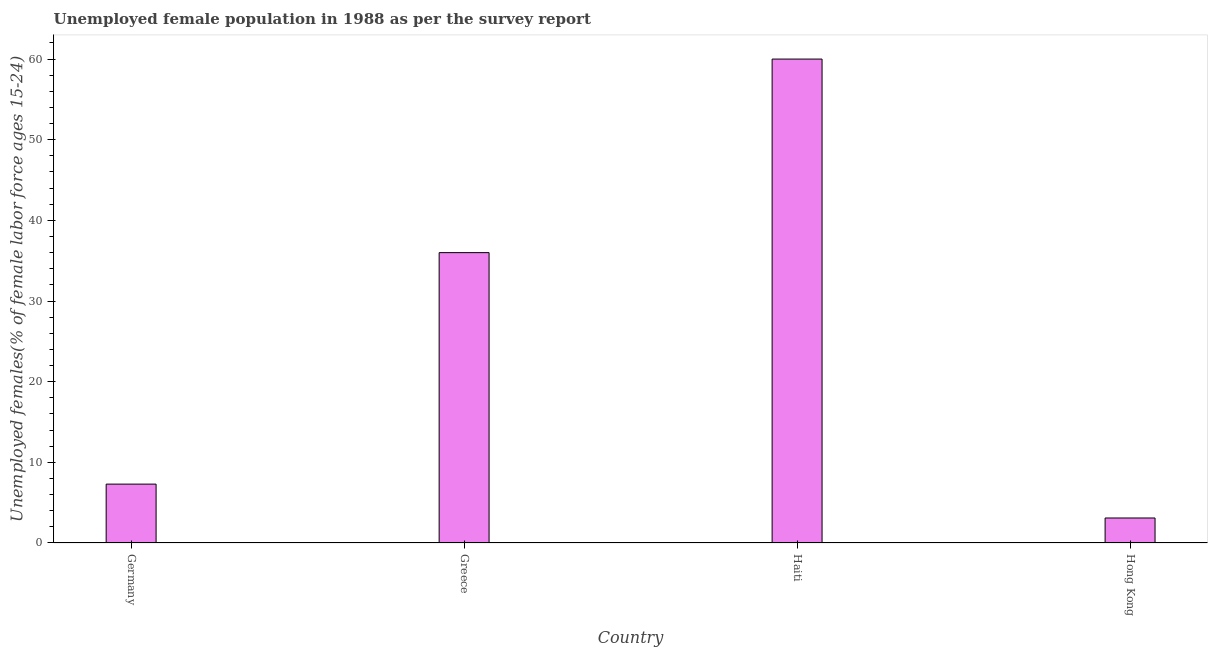Does the graph contain grids?
Your answer should be very brief. No. What is the title of the graph?
Provide a short and direct response. Unemployed female population in 1988 as per the survey report. What is the label or title of the X-axis?
Provide a succinct answer. Country. What is the label or title of the Y-axis?
Provide a succinct answer. Unemployed females(% of female labor force ages 15-24). Across all countries, what is the maximum unemployed female youth?
Keep it short and to the point. 60. Across all countries, what is the minimum unemployed female youth?
Offer a terse response. 3.1. In which country was the unemployed female youth maximum?
Keep it short and to the point. Haiti. In which country was the unemployed female youth minimum?
Offer a very short reply. Hong Kong. What is the sum of the unemployed female youth?
Give a very brief answer. 106.4. What is the difference between the unemployed female youth in Greece and Hong Kong?
Offer a terse response. 32.9. What is the average unemployed female youth per country?
Provide a short and direct response. 26.6. What is the median unemployed female youth?
Keep it short and to the point. 21.65. In how many countries, is the unemployed female youth greater than 48 %?
Your answer should be compact. 1. What is the ratio of the unemployed female youth in Greece to that in Hong Kong?
Provide a succinct answer. 11.61. Is the difference between the unemployed female youth in Haiti and Hong Kong greater than the difference between any two countries?
Your response must be concise. Yes. Is the sum of the unemployed female youth in Greece and Hong Kong greater than the maximum unemployed female youth across all countries?
Make the answer very short. No. What is the difference between the highest and the lowest unemployed female youth?
Provide a succinct answer. 56.9. Are all the bars in the graph horizontal?
Your answer should be very brief. No. What is the difference between two consecutive major ticks on the Y-axis?
Give a very brief answer. 10. What is the Unemployed females(% of female labor force ages 15-24) of Germany?
Ensure brevity in your answer.  7.3. What is the Unemployed females(% of female labor force ages 15-24) in Greece?
Ensure brevity in your answer.  36. What is the Unemployed females(% of female labor force ages 15-24) of Hong Kong?
Ensure brevity in your answer.  3.1. What is the difference between the Unemployed females(% of female labor force ages 15-24) in Germany and Greece?
Provide a short and direct response. -28.7. What is the difference between the Unemployed females(% of female labor force ages 15-24) in Germany and Haiti?
Ensure brevity in your answer.  -52.7. What is the difference between the Unemployed females(% of female labor force ages 15-24) in Germany and Hong Kong?
Provide a succinct answer. 4.2. What is the difference between the Unemployed females(% of female labor force ages 15-24) in Greece and Haiti?
Keep it short and to the point. -24. What is the difference between the Unemployed females(% of female labor force ages 15-24) in Greece and Hong Kong?
Your response must be concise. 32.9. What is the difference between the Unemployed females(% of female labor force ages 15-24) in Haiti and Hong Kong?
Make the answer very short. 56.9. What is the ratio of the Unemployed females(% of female labor force ages 15-24) in Germany to that in Greece?
Your answer should be very brief. 0.2. What is the ratio of the Unemployed females(% of female labor force ages 15-24) in Germany to that in Haiti?
Keep it short and to the point. 0.12. What is the ratio of the Unemployed females(% of female labor force ages 15-24) in Germany to that in Hong Kong?
Ensure brevity in your answer.  2.35. What is the ratio of the Unemployed females(% of female labor force ages 15-24) in Greece to that in Hong Kong?
Offer a very short reply. 11.61. What is the ratio of the Unemployed females(% of female labor force ages 15-24) in Haiti to that in Hong Kong?
Give a very brief answer. 19.36. 